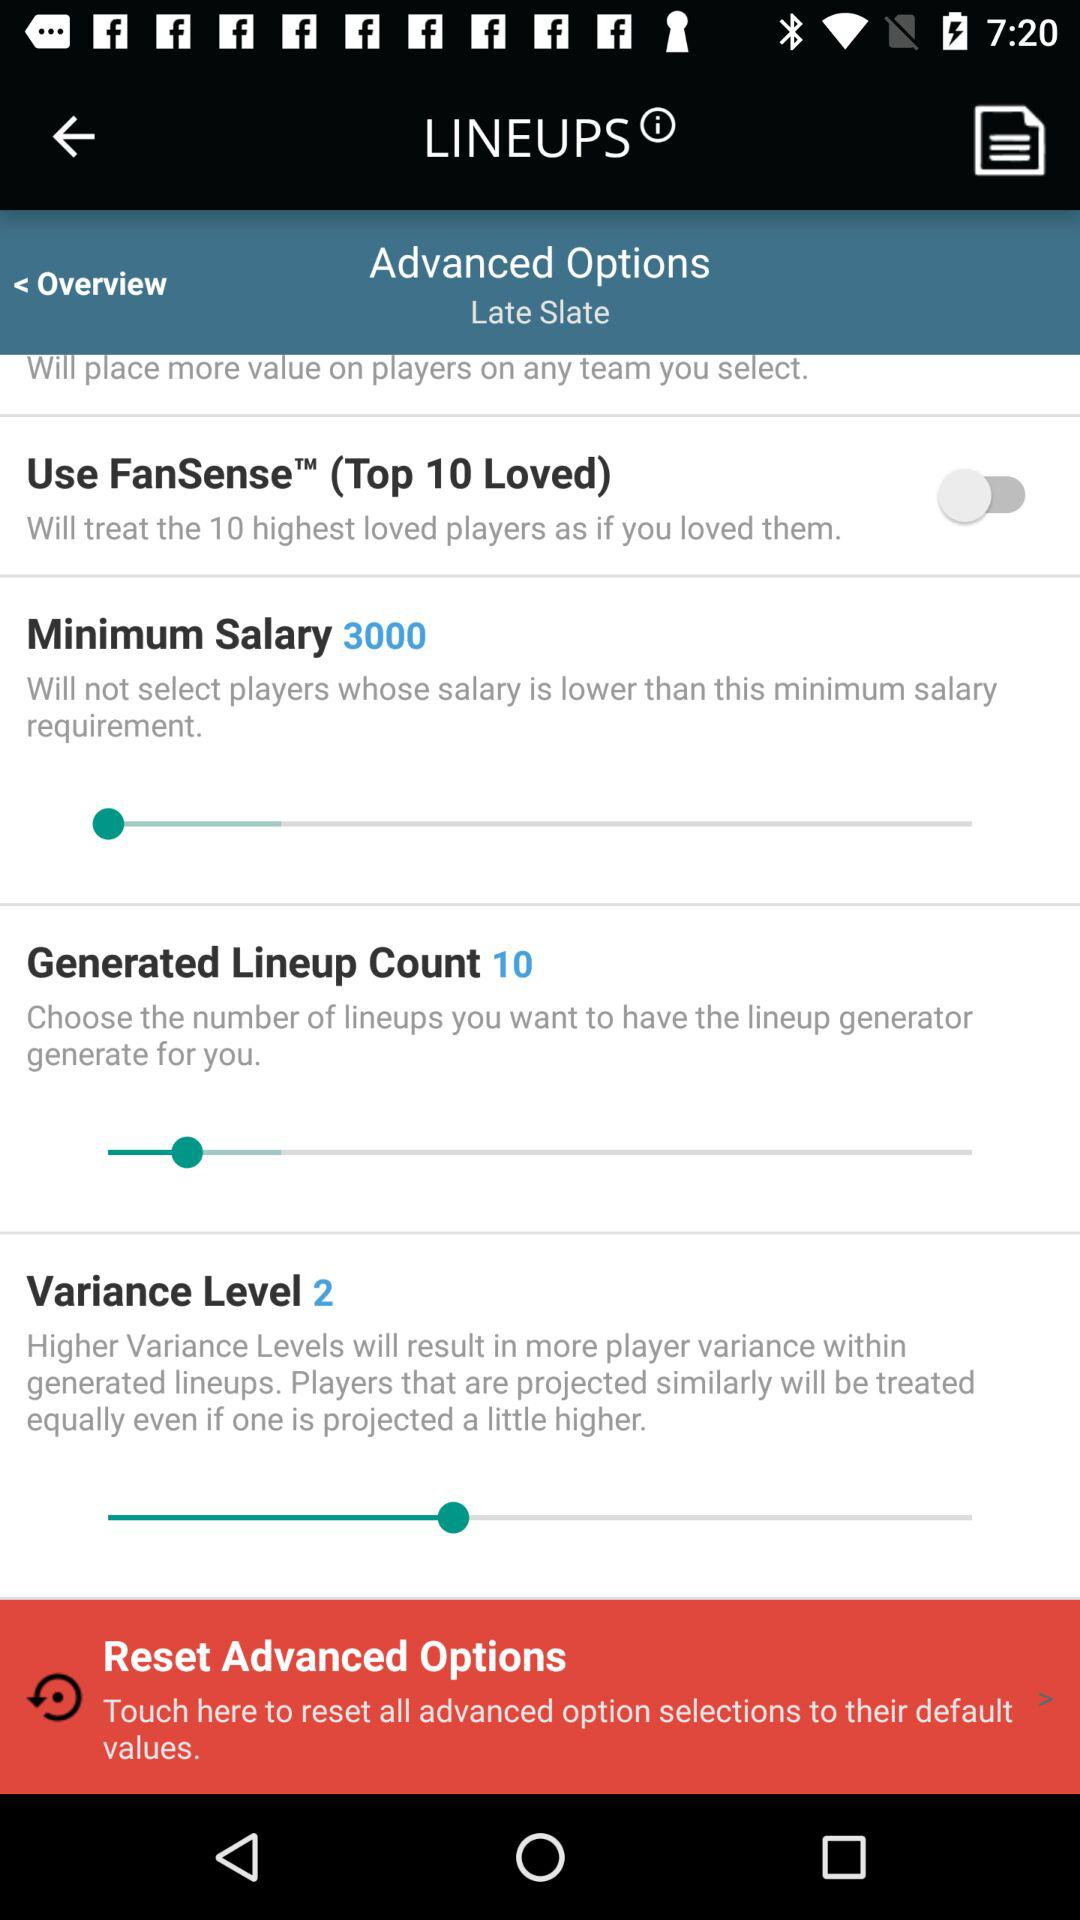What is the selected variance level? The selected variance level is 2. 